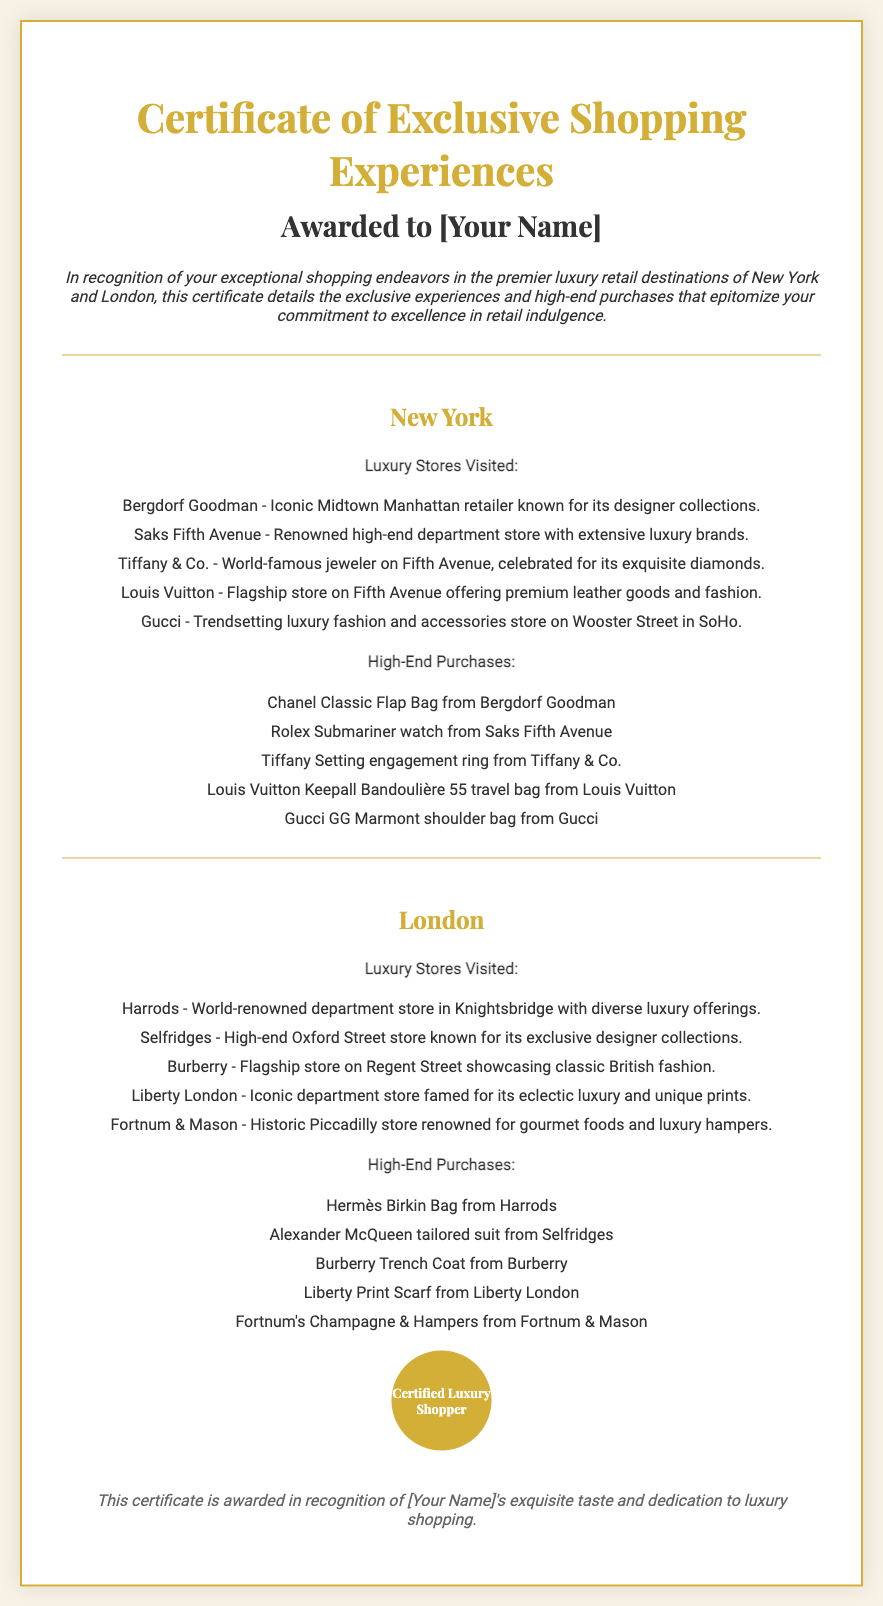Which store in New York is known for its diamonds? The specific luxury store focused on diamonds is detailed in the list of stores in New York.
Answer: Tiffany & Co How many luxury stores are listed for New York? The total number of luxury stores mentioned can be counted from the list provided in the document.
Answer: Five What is one high-end purchase made in London? The document includes a list of high-end purchases made in London, highlighting the luxury shopping experience.
Answer: Hermès Birkin Bag Which flagship store showcases classic British fashion? The reasoning involves recognizing the store from the detailed list of luxury stores visited in London.
Answer: Burberry What is the color of the certificate's border? The color of the border is described in the style section of the document, which visually frames the certificate.
Answer: Gold Who certified the luxury shopping experience? This refers to the phrase displayed within the seal section, indicating who is giving this certification.
Answer: Certified Luxury Shopper What is one of the purchases made from Saks Fifth Avenue? The document details specific high-end purchases made in New York and can be referenced for this information.
Answer: Rolex Submariner watch 